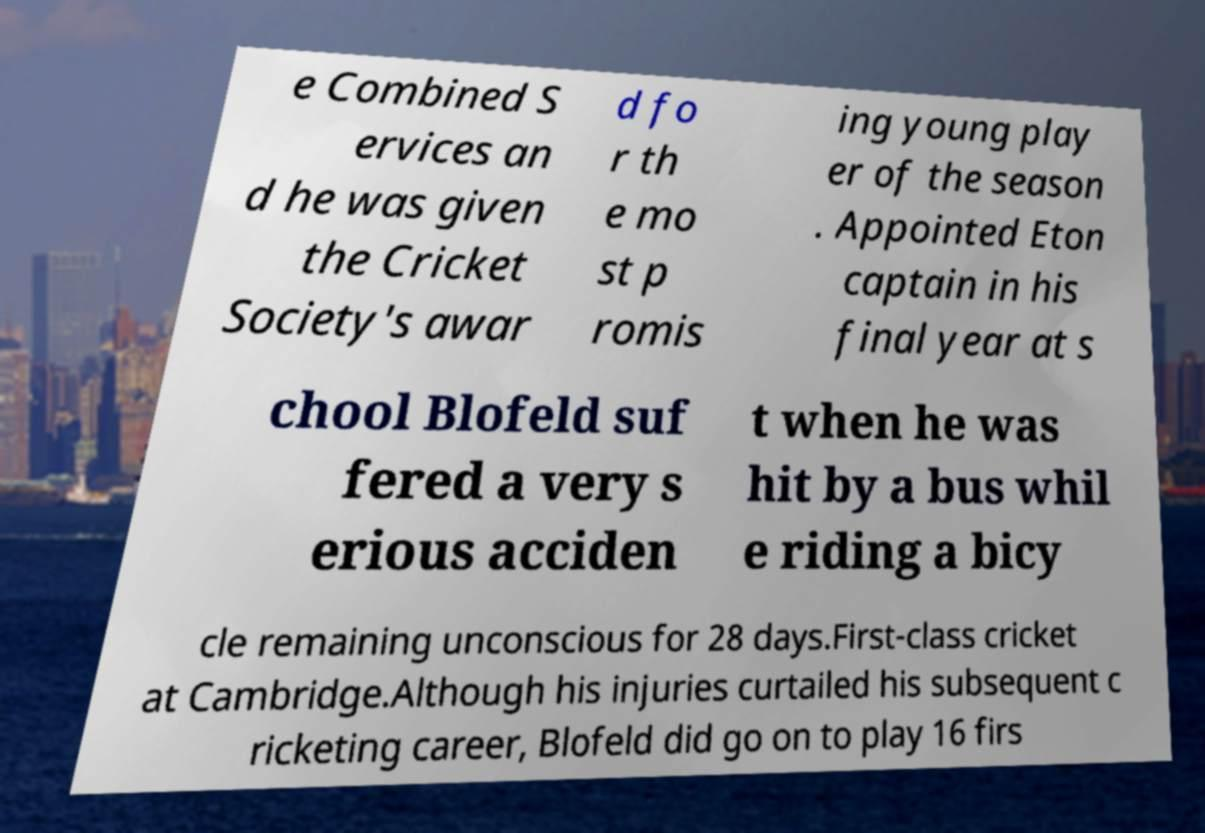I need the written content from this picture converted into text. Can you do that? e Combined S ervices an d he was given the Cricket Society's awar d fo r th e mo st p romis ing young play er of the season . Appointed Eton captain in his final year at s chool Blofeld suf fered a very s erious acciden t when he was hit by a bus whil e riding a bicy cle remaining unconscious for 28 days.First-class cricket at Cambridge.Although his injuries curtailed his subsequent c ricketing career, Blofeld did go on to play 16 firs 